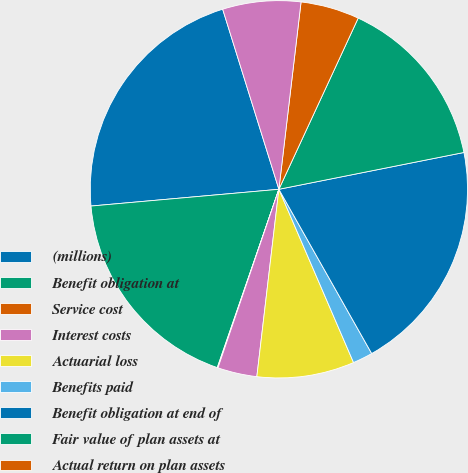Convert chart. <chart><loc_0><loc_0><loc_500><loc_500><pie_chart><fcel>(millions)<fcel>Benefit obligation at<fcel>Service cost<fcel>Interest costs<fcel>Actuarial loss<fcel>Benefits paid<fcel>Benefit obligation at end of<fcel>Fair value of plan assets at<fcel>Actual return on plan assets<fcel>Employer contributions<nl><fcel>21.6%<fcel>18.29%<fcel>0.06%<fcel>3.37%<fcel>8.34%<fcel>1.71%<fcel>19.94%<fcel>14.97%<fcel>5.03%<fcel>6.69%<nl></chart> 